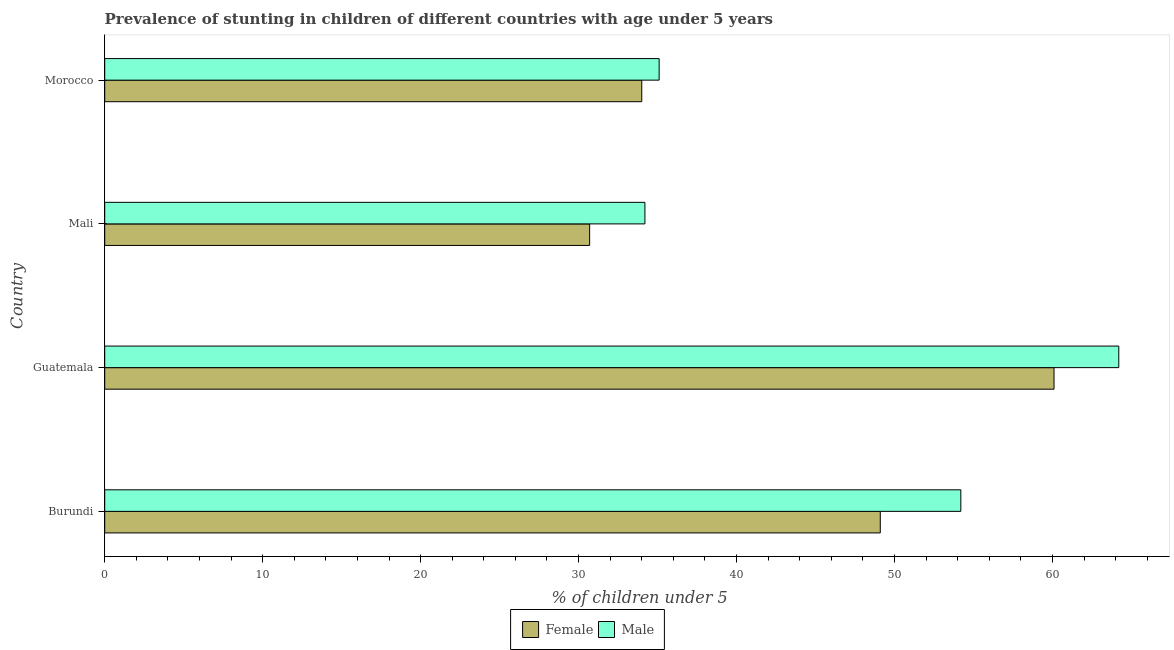How many different coloured bars are there?
Give a very brief answer. 2. What is the label of the 2nd group of bars from the top?
Offer a terse response. Mali. What is the percentage of stunted male children in Morocco?
Your answer should be compact. 35.1. Across all countries, what is the maximum percentage of stunted male children?
Your answer should be compact. 64.2. Across all countries, what is the minimum percentage of stunted female children?
Your response must be concise. 30.7. In which country was the percentage of stunted male children maximum?
Keep it short and to the point. Guatemala. In which country was the percentage of stunted male children minimum?
Your answer should be very brief. Mali. What is the total percentage of stunted male children in the graph?
Offer a terse response. 187.7. What is the difference between the percentage of stunted female children in Guatemala and that in Morocco?
Make the answer very short. 26.1. What is the difference between the percentage of stunted male children in Burundi and the percentage of stunted female children in Guatemala?
Give a very brief answer. -5.9. What is the average percentage of stunted female children per country?
Ensure brevity in your answer.  43.48. What is the difference between the percentage of stunted female children and percentage of stunted male children in Mali?
Your response must be concise. -3.5. In how many countries, is the percentage of stunted male children greater than 48 %?
Provide a short and direct response. 2. What is the ratio of the percentage of stunted female children in Mali to that in Morocco?
Keep it short and to the point. 0.9. Is the percentage of stunted female children in Mali less than that in Morocco?
Offer a very short reply. Yes. What is the difference between the highest and the second highest percentage of stunted female children?
Give a very brief answer. 11. What is the difference between the highest and the lowest percentage of stunted female children?
Ensure brevity in your answer.  29.4. In how many countries, is the percentage of stunted female children greater than the average percentage of stunted female children taken over all countries?
Your response must be concise. 2. Is the sum of the percentage of stunted male children in Guatemala and Mali greater than the maximum percentage of stunted female children across all countries?
Provide a short and direct response. Yes. Are all the bars in the graph horizontal?
Ensure brevity in your answer.  Yes. How many countries are there in the graph?
Ensure brevity in your answer.  4. Are the values on the major ticks of X-axis written in scientific E-notation?
Keep it short and to the point. No. Does the graph contain any zero values?
Provide a short and direct response. No. Where does the legend appear in the graph?
Provide a short and direct response. Bottom center. How many legend labels are there?
Ensure brevity in your answer.  2. How are the legend labels stacked?
Offer a very short reply. Horizontal. What is the title of the graph?
Provide a succinct answer. Prevalence of stunting in children of different countries with age under 5 years. What is the label or title of the X-axis?
Your answer should be very brief.  % of children under 5. What is the label or title of the Y-axis?
Ensure brevity in your answer.  Country. What is the  % of children under 5 in Female in Burundi?
Your response must be concise. 49.1. What is the  % of children under 5 of Male in Burundi?
Offer a very short reply. 54.2. What is the  % of children under 5 of Female in Guatemala?
Give a very brief answer. 60.1. What is the  % of children under 5 of Male in Guatemala?
Give a very brief answer. 64.2. What is the  % of children under 5 in Female in Mali?
Offer a very short reply. 30.7. What is the  % of children under 5 in Male in Mali?
Provide a short and direct response. 34.2. What is the  % of children under 5 of Male in Morocco?
Provide a short and direct response. 35.1. Across all countries, what is the maximum  % of children under 5 in Female?
Offer a very short reply. 60.1. Across all countries, what is the maximum  % of children under 5 of Male?
Your response must be concise. 64.2. Across all countries, what is the minimum  % of children under 5 in Female?
Offer a terse response. 30.7. Across all countries, what is the minimum  % of children under 5 of Male?
Provide a short and direct response. 34.2. What is the total  % of children under 5 in Female in the graph?
Keep it short and to the point. 173.9. What is the total  % of children under 5 in Male in the graph?
Ensure brevity in your answer.  187.7. What is the difference between the  % of children under 5 in Female in Burundi and that in Guatemala?
Offer a terse response. -11. What is the difference between the  % of children under 5 of Female in Burundi and that in Mali?
Your answer should be compact. 18.4. What is the difference between the  % of children under 5 in Male in Burundi and that in Mali?
Make the answer very short. 20. What is the difference between the  % of children under 5 of Female in Burundi and that in Morocco?
Provide a succinct answer. 15.1. What is the difference between the  % of children under 5 in Female in Guatemala and that in Mali?
Ensure brevity in your answer.  29.4. What is the difference between the  % of children under 5 of Female in Guatemala and that in Morocco?
Provide a succinct answer. 26.1. What is the difference between the  % of children under 5 of Male in Guatemala and that in Morocco?
Your response must be concise. 29.1. What is the difference between the  % of children under 5 in Male in Mali and that in Morocco?
Offer a very short reply. -0.9. What is the difference between the  % of children under 5 of Female in Burundi and the  % of children under 5 of Male in Guatemala?
Your answer should be compact. -15.1. What is the difference between the  % of children under 5 of Female in Burundi and the  % of children under 5 of Male in Mali?
Provide a succinct answer. 14.9. What is the difference between the  % of children under 5 of Female in Guatemala and the  % of children under 5 of Male in Mali?
Give a very brief answer. 25.9. What is the difference between the  % of children under 5 of Female in Mali and the  % of children under 5 of Male in Morocco?
Your answer should be very brief. -4.4. What is the average  % of children under 5 of Female per country?
Give a very brief answer. 43.48. What is the average  % of children under 5 of Male per country?
Provide a short and direct response. 46.92. What is the difference between the  % of children under 5 of Female and  % of children under 5 of Male in Burundi?
Offer a very short reply. -5.1. What is the difference between the  % of children under 5 of Female and  % of children under 5 of Male in Guatemala?
Ensure brevity in your answer.  -4.1. What is the difference between the  % of children under 5 in Female and  % of children under 5 in Male in Mali?
Make the answer very short. -3.5. What is the ratio of the  % of children under 5 in Female in Burundi to that in Guatemala?
Offer a terse response. 0.82. What is the ratio of the  % of children under 5 of Male in Burundi to that in Guatemala?
Offer a very short reply. 0.84. What is the ratio of the  % of children under 5 of Female in Burundi to that in Mali?
Give a very brief answer. 1.6. What is the ratio of the  % of children under 5 of Male in Burundi to that in Mali?
Give a very brief answer. 1.58. What is the ratio of the  % of children under 5 in Female in Burundi to that in Morocco?
Your answer should be very brief. 1.44. What is the ratio of the  % of children under 5 in Male in Burundi to that in Morocco?
Offer a terse response. 1.54. What is the ratio of the  % of children under 5 in Female in Guatemala to that in Mali?
Offer a very short reply. 1.96. What is the ratio of the  % of children under 5 in Male in Guatemala to that in Mali?
Offer a terse response. 1.88. What is the ratio of the  % of children under 5 in Female in Guatemala to that in Morocco?
Your response must be concise. 1.77. What is the ratio of the  % of children under 5 of Male in Guatemala to that in Morocco?
Your response must be concise. 1.83. What is the ratio of the  % of children under 5 of Female in Mali to that in Morocco?
Your answer should be very brief. 0.9. What is the ratio of the  % of children under 5 in Male in Mali to that in Morocco?
Give a very brief answer. 0.97. What is the difference between the highest and the second highest  % of children under 5 in Female?
Your answer should be compact. 11. What is the difference between the highest and the lowest  % of children under 5 of Female?
Provide a succinct answer. 29.4. What is the difference between the highest and the lowest  % of children under 5 in Male?
Give a very brief answer. 30. 